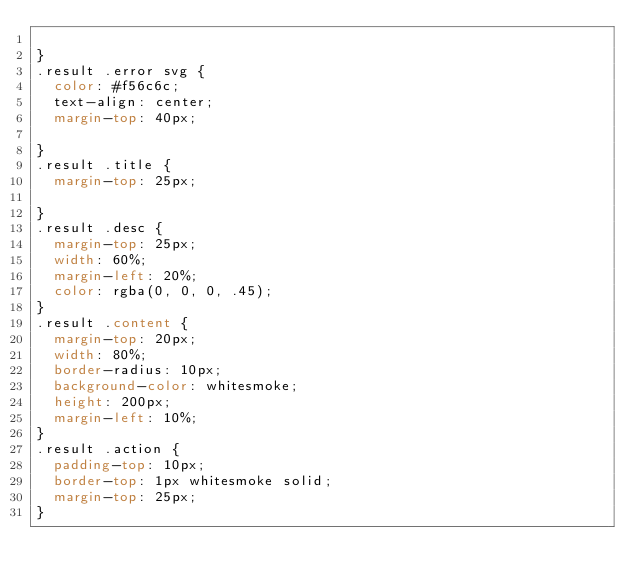<code> <loc_0><loc_0><loc_500><loc_500><_CSS_>
}
.result .error svg {
	color: #f56c6c;
	text-align: center;
	margin-top: 40px;

}
.result .title {
	margin-top: 25px;

}
.result .desc {
	margin-top: 25px;
	width: 60%;
	margin-left: 20%;
	color: rgba(0, 0, 0, .45);
}
.result .content {
	margin-top: 20px;
	width: 80%;
	border-radius: 10px;
	background-color: whitesmoke;
	height: 200px;
	margin-left: 10%;
}
.result .action {
	padding-top: 10px;
	border-top: 1px whitesmoke solid;
	margin-top: 25px;
}
</code> 